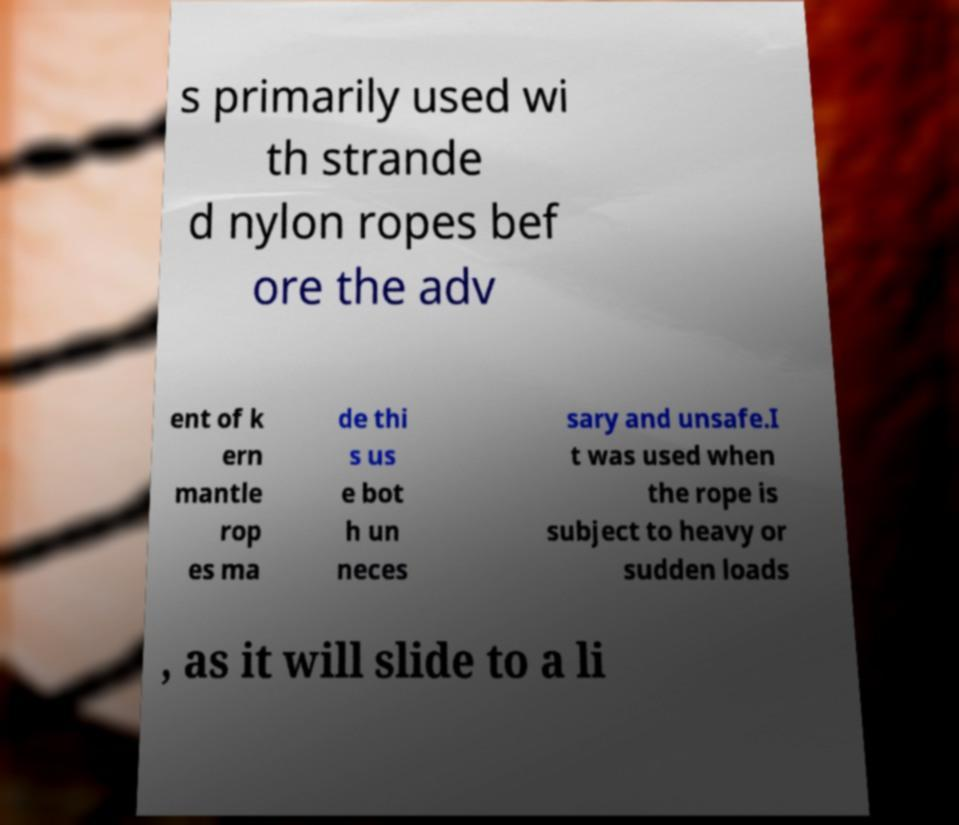There's text embedded in this image that I need extracted. Can you transcribe it verbatim? s primarily used wi th strande d nylon ropes bef ore the adv ent of k ern mantle rop es ma de thi s us e bot h un neces sary and unsafe.I t was used when the rope is subject to heavy or sudden loads , as it will slide to a li 